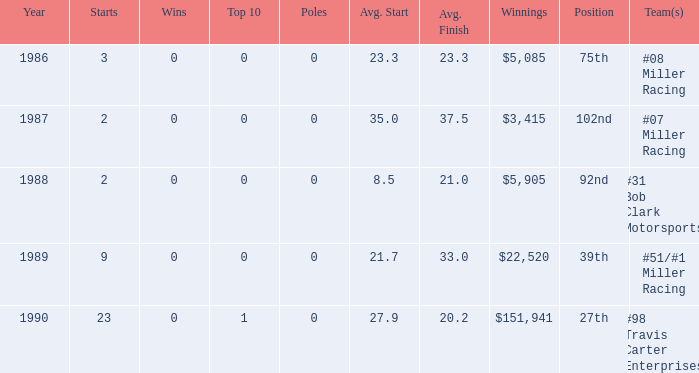5? 1988.0. 